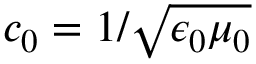<formula> <loc_0><loc_0><loc_500><loc_500>c _ { 0 } = 1 / \sqrt { \epsilon _ { 0 } \mu _ { 0 } }</formula> 